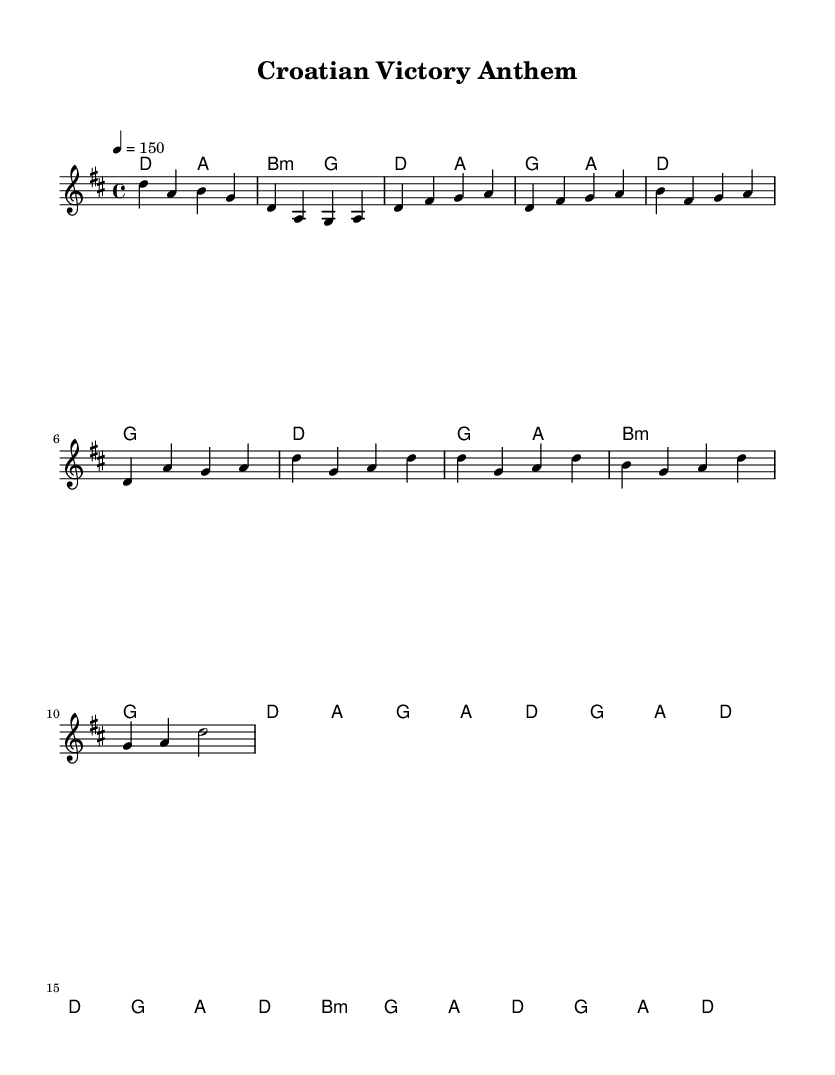What is the key signature of this music? The key signature is D major, which has two sharps (F# and C#). This is indicated at the beginning of the sheet music.
Answer: D major What is the time signature of this music? The time signature is 4/4, which is found at the beginning of the sheet music. This means there are four beats in each measure and the quarter note receives one beat.
Answer: 4/4 What is the tempo marking of this piece? The tempo marking indicates a tempo of 150 beats per minute, as shown at the beginning of the score.
Answer: 150 How many chords are in the verses section of the song? By examining the chord progression in the "Verse" section, there are a total of 8 chords: D, G, D, G, Bm, G, D, A.
Answer: 8 What is the last chord of the chorus? The last chord of the "Chorus" section is D major as indicated in the harmony line just before the score concludes.
Answer: D What type of song structure is represented here? The structure includes an intro, verses, and a chorus, which is typical for country rock songs that focus on storytelling and energy.
Answer: Intro, Verse, Chorus Which section contains the highest note? The "Verse" section includes the highest note, A, which is found amidst the melody. This is determined by scanning the melody line for the highest pitch.
Answer: A 